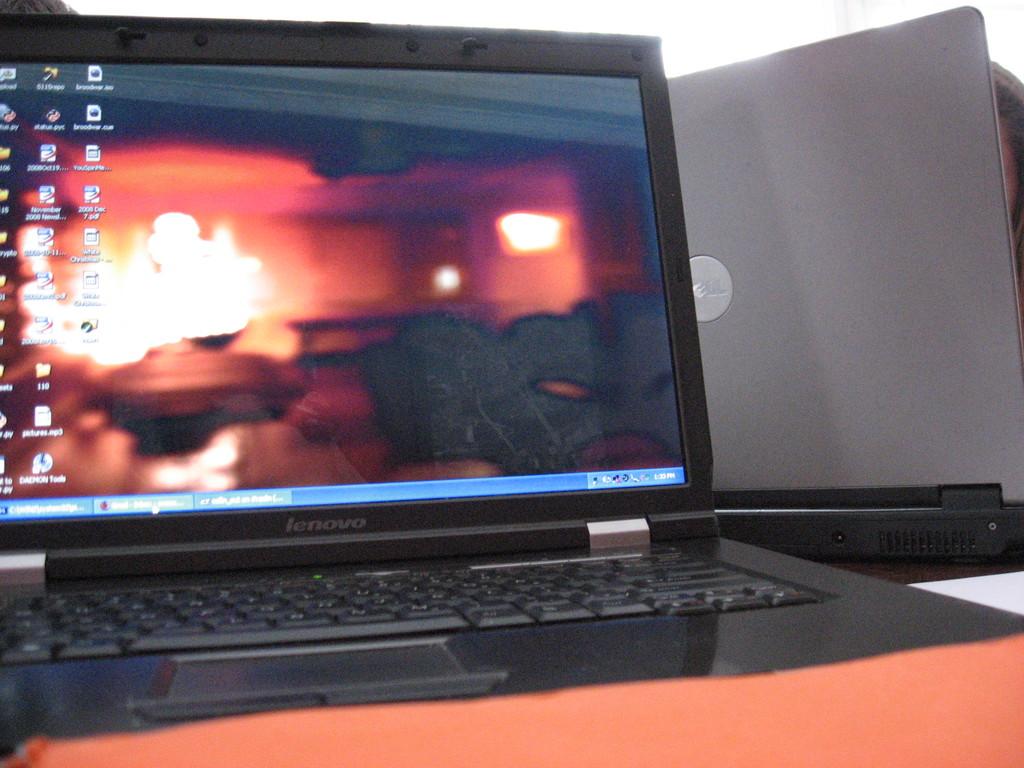What is the laptop brand?
Keep it short and to the point. Lenovo. 